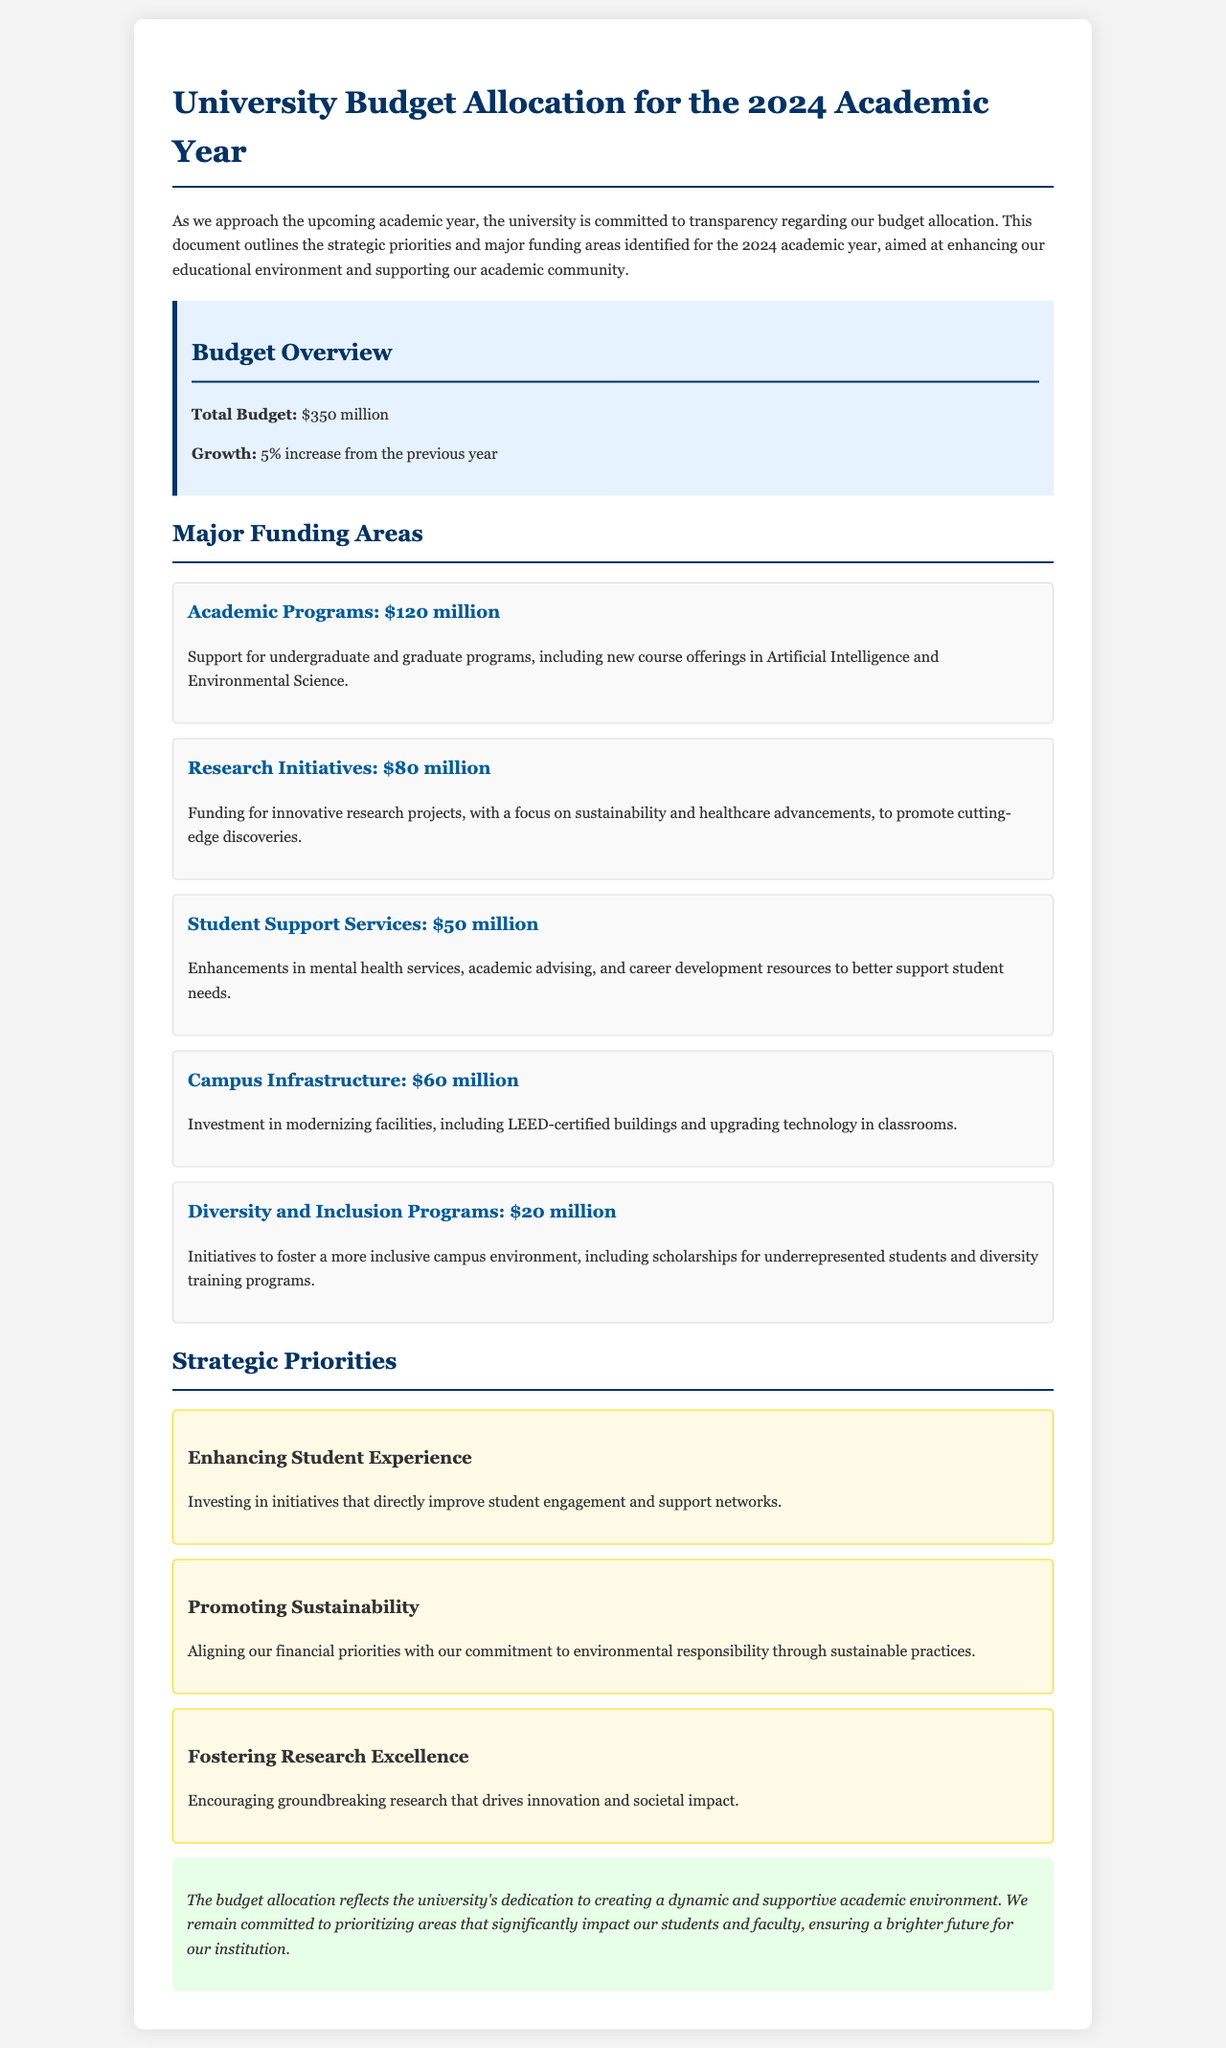What is the total budget for the 2024 academic year? The total budget is stated in the document as the overall budget for the upcoming academic year.
Answer: $350 million What is the growth percentage from the previous year? The growth percentage refers to the increase in the budget compared to the last academic year, as provided in the overview.
Answer: 5% How much is allocated for Academic Programs? This figure represents the specific funding area designated for supporting academic programs as outlined in the document.
Answer: $120 million What funding area has the least budget allocated? This question identifies the area that received the smallest funding allocation based on the listed amounts in the document.
Answer: Diversity and Inclusion Programs What are the key strategic priorities mentioned? This asks for the main focus areas identified for the upcoming year, as they reflect the university's goals.
Answer: Enhancing Student Experience, Promoting Sustainability, Fostering Research Excellence How much is allocated for Research Initiatives? This amount is specifically dedicated to research projects mentioned in the funding areas section.
Answer: $80 million What is one major initiative under Student Support Services? This question looks for specific enhancements mentioned that fall under the category of student support.
Answer: Mental health services What does the budget allocation reflect about the university's commitment? This seeks to find a deeper understanding of the implications of the budget decisions stated in the conclusion.
Answer: Creating a dynamic and supportive academic environment How is funding for Campus Infrastructure aimed to be used? The question seeks to know the intended use of the budget for infrastructure improvements, as mentioned in the funding area.
Answer: Modernizing facilities 